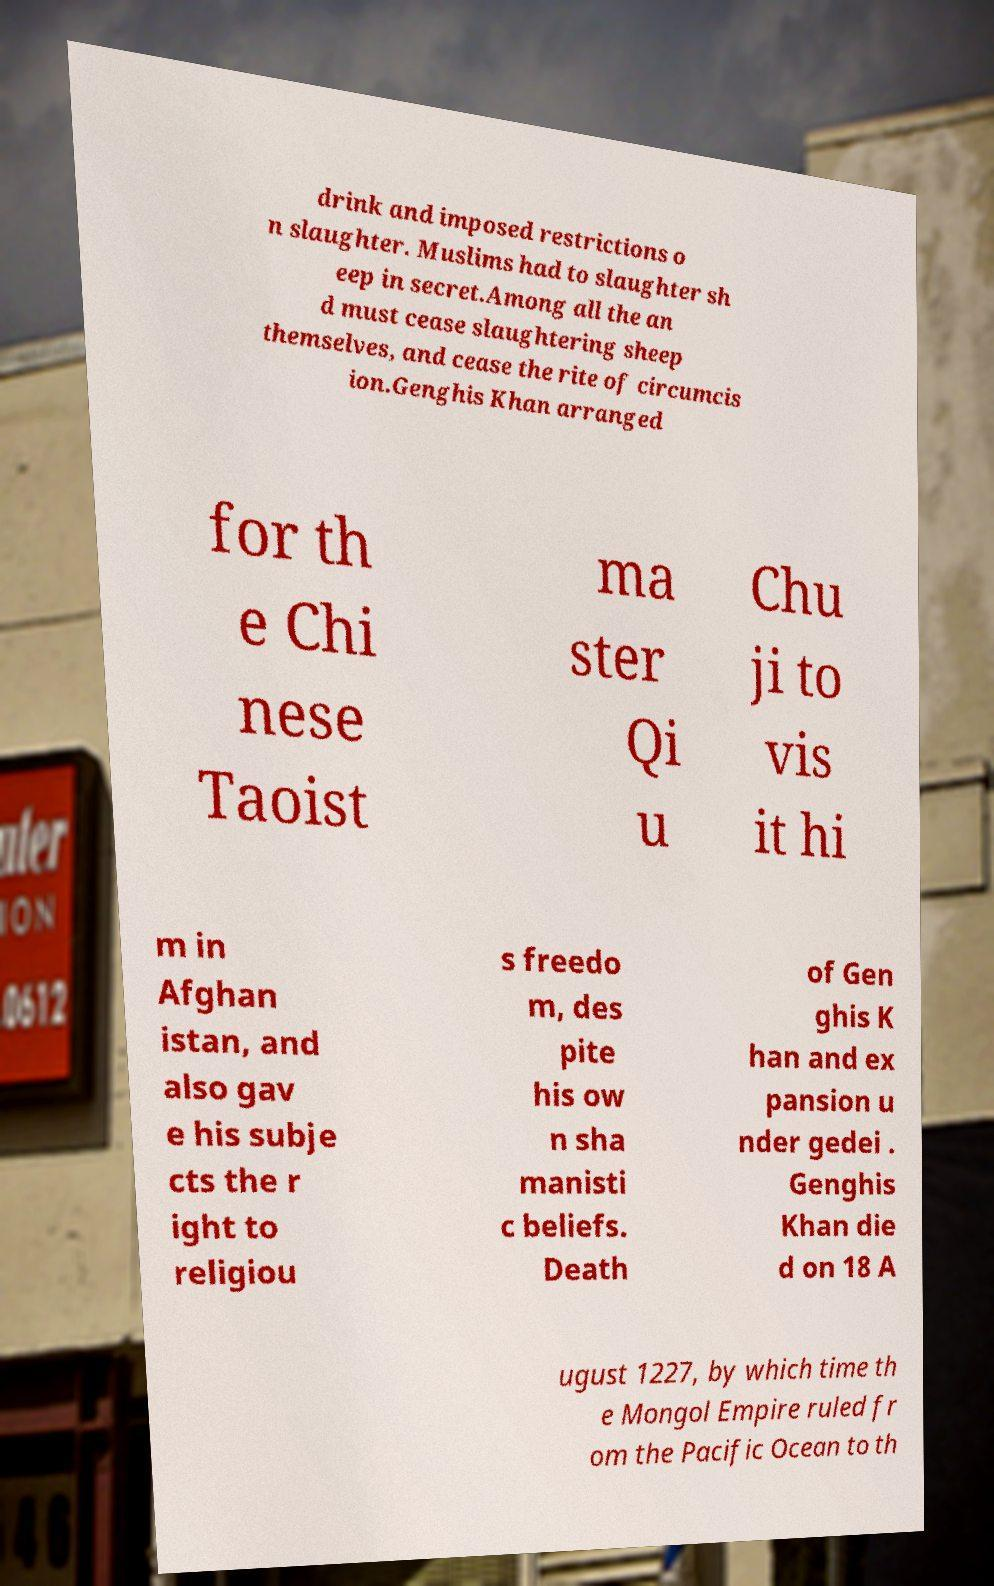Could you assist in decoding the text presented in this image and type it out clearly? drink and imposed restrictions o n slaughter. Muslims had to slaughter sh eep in secret.Among all the an d must cease slaughtering sheep themselves, and cease the rite of circumcis ion.Genghis Khan arranged for th e Chi nese Taoist ma ster Qi u Chu ji to vis it hi m in Afghan istan, and also gav e his subje cts the r ight to religiou s freedo m, des pite his ow n sha manisti c beliefs. Death of Gen ghis K han and ex pansion u nder gedei . Genghis Khan die d on 18 A ugust 1227, by which time th e Mongol Empire ruled fr om the Pacific Ocean to th 